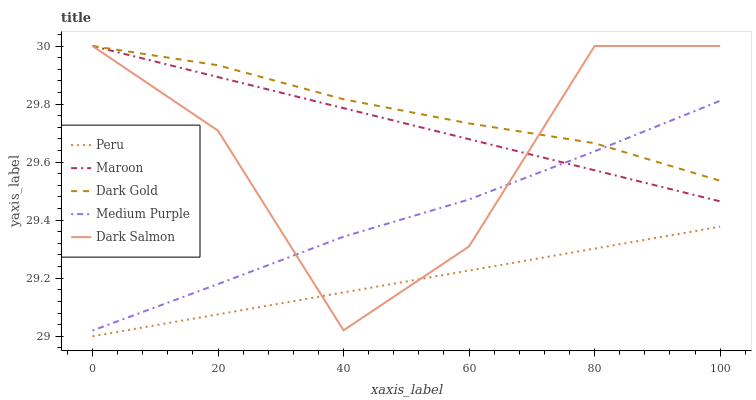Does Peru have the minimum area under the curve?
Answer yes or no. Yes. Does Dark Gold have the maximum area under the curve?
Answer yes or no. Yes. Does Dark Salmon have the minimum area under the curve?
Answer yes or no. No. Does Dark Salmon have the maximum area under the curve?
Answer yes or no. No. Is Peru the smoothest?
Answer yes or no. Yes. Is Dark Salmon the roughest?
Answer yes or no. Yes. Is Maroon the smoothest?
Answer yes or no. No. Is Maroon the roughest?
Answer yes or no. No. Does Dark Salmon have the lowest value?
Answer yes or no. No. Does Dark Gold have the highest value?
Answer yes or no. Yes. Does Peru have the highest value?
Answer yes or no. No. Is Peru less than Dark Gold?
Answer yes or no. Yes. Is Medium Purple greater than Peru?
Answer yes or no. Yes. Does Dark Salmon intersect Maroon?
Answer yes or no. Yes. Is Dark Salmon less than Maroon?
Answer yes or no. No. Is Dark Salmon greater than Maroon?
Answer yes or no. No. Does Peru intersect Dark Gold?
Answer yes or no. No. 